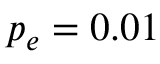Convert formula to latex. <formula><loc_0><loc_0><loc_500><loc_500>p _ { e } = 0 . 0 1</formula> 